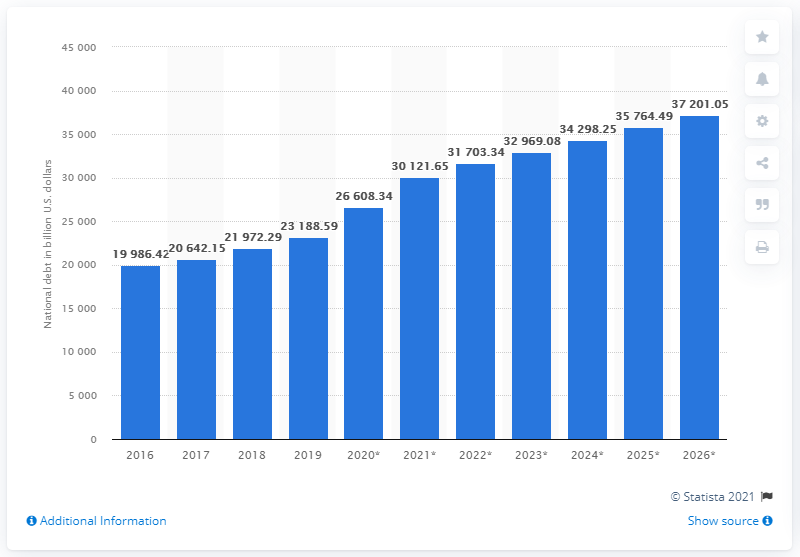Indicate a few pertinent items in this graphic. As of 2019, the debt of the United States was approximately 23188.59 dollars. 